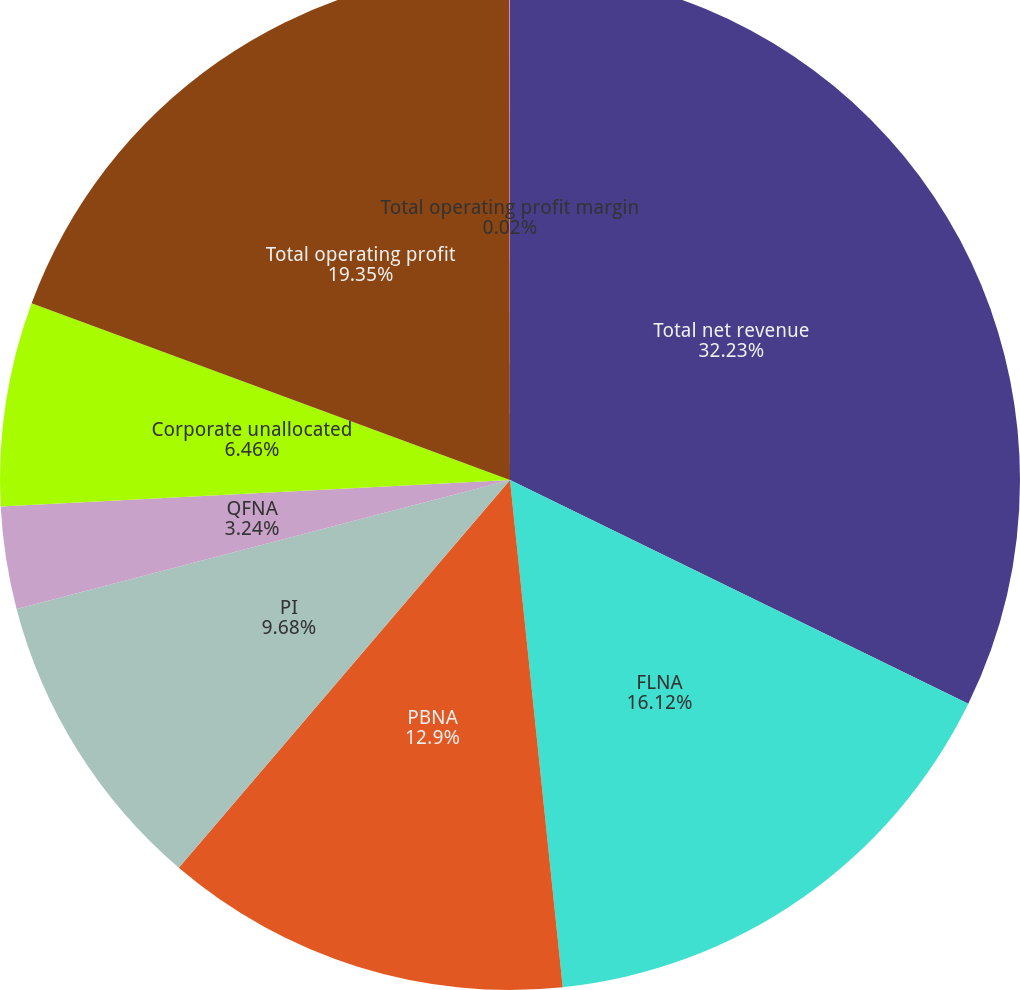<chart> <loc_0><loc_0><loc_500><loc_500><pie_chart><fcel>Total net revenue<fcel>FLNA<fcel>PBNA<fcel>PI<fcel>QFNA<fcel>Corporate unallocated<fcel>Total operating profit<fcel>Total operating profit margin<nl><fcel>32.23%<fcel>16.12%<fcel>12.9%<fcel>9.68%<fcel>3.24%<fcel>6.46%<fcel>19.35%<fcel>0.02%<nl></chart> 